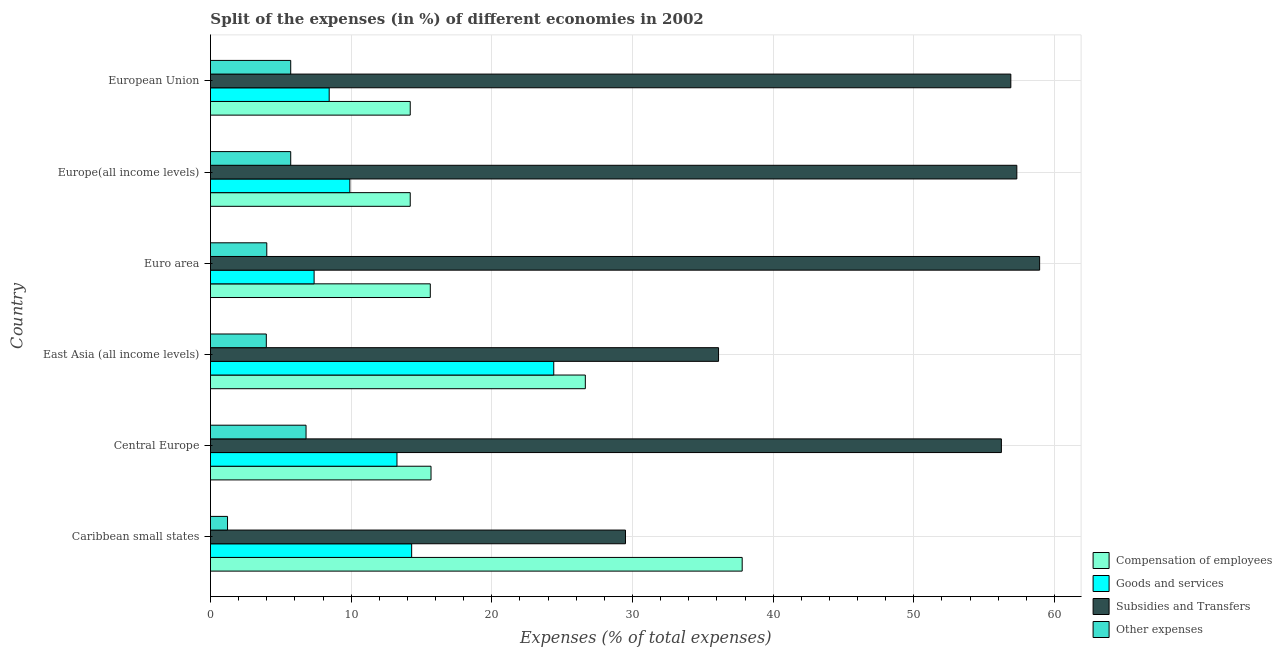How many different coloured bars are there?
Offer a very short reply. 4. Are the number of bars on each tick of the Y-axis equal?
Provide a succinct answer. Yes. How many bars are there on the 5th tick from the top?
Your response must be concise. 4. How many bars are there on the 3rd tick from the bottom?
Ensure brevity in your answer.  4. What is the label of the 6th group of bars from the top?
Your answer should be very brief. Caribbean small states. What is the percentage of amount spent on subsidies in East Asia (all income levels)?
Keep it short and to the point. 36.12. Across all countries, what is the maximum percentage of amount spent on subsidies?
Offer a terse response. 58.94. Across all countries, what is the minimum percentage of amount spent on compensation of employees?
Your answer should be very brief. 14.2. In which country was the percentage of amount spent on other expenses maximum?
Your response must be concise. Central Europe. In which country was the percentage of amount spent on other expenses minimum?
Ensure brevity in your answer.  Caribbean small states. What is the total percentage of amount spent on subsidies in the graph?
Provide a short and direct response. 295. What is the difference between the percentage of amount spent on subsidies in Euro area and that in Europe(all income levels)?
Provide a short and direct response. 1.62. What is the difference between the percentage of amount spent on other expenses in Central Europe and the percentage of amount spent on subsidies in Euro area?
Your answer should be compact. -52.15. What is the average percentage of amount spent on other expenses per country?
Your response must be concise. 4.56. What is the difference between the percentage of amount spent on compensation of employees and percentage of amount spent on other expenses in Euro area?
Provide a short and direct response. 11.62. In how many countries, is the percentage of amount spent on other expenses greater than 18 %?
Provide a succinct answer. 0. What is the ratio of the percentage of amount spent on compensation of employees in Central Europe to that in European Union?
Ensure brevity in your answer.  1.1. Is the percentage of amount spent on subsidies in Caribbean small states less than that in East Asia (all income levels)?
Keep it short and to the point. Yes. Is the difference between the percentage of amount spent on goods and services in Central Europe and Euro area greater than the difference between the percentage of amount spent on compensation of employees in Central Europe and Euro area?
Keep it short and to the point. Yes. What is the difference between the highest and the second highest percentage of amount spent on goods and services?
Provide a succinct answer. 10.1. What is the difference between the highest and the lowest percentage of amount spent on subsidies?
Ensure brevity in your answer.  29.44. Is the sum of the percentage of amount spent on subsidies in Caribbean small states and East Asia (all income levels) greater than the maximum percentage of amount spent on compensation of employees across all countries?
Your answer should be very brief. Yes. Is it the case that in every country, the sum of the percentage of amount spent on subsidies and percentage of amount spent on goods and services is greater than the sum of percentage of amount spent on other expenses and percentage of amount spent on compensation of employees?
Give a very brief answer. Yes. What does the 3rd bar from the top in Caribbean small states represents?
Make the answer very short. Goods and services. What does the 4th bar from the bottom in East Asia (all income levels) represents?
Ensure brevity in your answer.  Other expenses. Is it the case that in every country, the sum of the percentage of amount spent on compensation of employees and percentage of amount spent on goods and services is greater than the percentage of amount spent on subsidies?
Your response must be concise. No. How many bars are there?
Your response must be concise. 24. How many countries are there in the graph?
Offer a terse response. 6. What is the difference between two consecutive major ticks on the X-axis?
Your answer should be compact. 10. Are the values on the major ticks of X-axis written in scientific E-notation?
Your answer should be very brief. No. Does the graph contain any zero values?
Make the answer very short. No. Where does the legend appear in the graph?
Give a very brief answer. Bottom right. What is the title of the graph?
Your response must be concise. Split of the expenses (in %) of different economies in 2002. What is the label or title of the X-axis?
Offer a very short reply. Expenses (% of total expenses). What is the label or title of the Y-axis?
Offer a very short reply. Country. What is the Expenses (% of total expenses) of Compensation of employees in Caribbean small states?
Your answer should be compact. 37.8. What is the Expenses (% of total expenses) of Goods and services in Caribbean small states?
Provide a succinct answer. 14.3. What is the Expenses (% of total expenses) in Subsidies and Transfers in Caribbean small states?
Give a very brief answer. 29.5. What is the Expenses (% of total expenses) in Other expenses in Caribbean small states?
Ensure brevity in your answer.  1.21. What is the Expenses (% of total expenses) of Compensation of employees in Central Europe?
Ensure brevity in your answer.  15.68. What is the Expenses (% of total expenses) of Goods and services in Central Europe?
Keep it short and to the point. 13.26. What is the Expenses (% of total expenses) in Subsidies and Transfers in Central Europe?
Make the answer very short. 56.22. What is the Expenses (% of total expenses) in Other expenses in Central Europe?
Your answer should be compact. 6.79. What is the Expenses (% of total expenses) of Compensation of employees in East Asia (all income levels)?
Provide a short and direct response. 26.65. What is the Expenses (% of total expenses) in Goods and services in East Asia (all income levels)?
Your answer should be compact. 24.4. What is the Expenses (% of total expenses) in Subsidies and Transfers in East Asia (all income levels)?
Provide a short and direct response. 36.12. What is the Expenses (% of total expenses) in Other expenses in East Asia (all income levels)?
Your response must be concise. 3.97. What is the Expenses (% of total expenses) in Compensation of employees in Euro area?
Ensure brevity in your answer.  15.63. What is the Expenses (% of total expenses) of Goods and services in Euro area?
Ensure brevity in your answer.  7.37. What is the Expenses (% of total expenses) of Subsidies and Transfers in Euro area?
Give a very brief answer. 58.94. What is the Expenses (% of total expenses) in Other expenses in Euro area?
Provide a succinct answer. 4. What is the Expenses (% of total expenses) in Compensation of employees in Europe(all income levels)?
Your answer should be compact. 14.2. What is the Expenses (% of total expenses) in Goods and services in Europe(all income levels)?
Provide a short and direct response. 9.91. What is the Expenses (% of total expenses) of Subsidies and Transfers in Europe(all income levels)?
Your answer should be compact. 57.32. What is the Expenses (% of total expenses) in Other expenses in Europe(all income levels)?
Your answer should be very brief. 5.7. What is the Expenses (% of total expenses) in Compensation of employees in European Union?
Your answer should be very brief. 14.2. What is the Expenses (% of total expenses) of Goods and services in European Union?
Offer a terse response. 8.44. What is the Expenses (% of total expenses) in Subsidies and Transfers in European Union?
Make the answer very short. 56.89. What is the Expenses (% of total expenses) of Other expenses in European Union?
Make the answer very short. 5.7. Across all countries, what is the maximum Expenses (% of total expenses) of Compensation of employees?
Offer a very short reply. 37.8. Across all countries, what is the maximum Expenses (% of total expenses) in Goods and services?
Your answer should be compact. 24.4. Across all countries, what is the maximum Expenses (% of total expenses) in Subsidies and Transfers?
Keep it short and to the point. 58.94. Across all countries, what is the maximum Expenses (% of total expenses) of Other expenses?
Provide a succinct answer. 6.79. Across all countries, what is the minimum Expenses (% of total expenses) of Compensation of employees?
Make the answer very short. 14.2. Across all countries, what is the minimum Expenses (% of total expenses) in Goods and services?
Offer a very short reply. 7.37. Across all countries, what is the minimum Expenses (% of total expenses) in Subsidies and Transfers?
Keep it short and to the point. 29.5. Across all countries, what is the minimum Expenses (% of total expenses) of Other expenses?
Offer a terse response. 1.21. What is the total Expenses (% of total expenses) of Compensation of employees in the graph?
Your answer should be compact. 124.15. What is the total Expenses (% of total expenses) of Goods and services in the graph?
Provide a succinct answer. 77.67. What is the total Expenses (% of total expenses) in Subsidies and Transfers in the graph?
Provide a short and direct response. 295. What is the total Expenses (% of total expenses) in Other expenses in the graph?
Provide a short and direct response. 27.39. What is the difference between the Expenses (% of total expenses) of Compensation of employees in Caribbean small states and that in Central Europe?
Offer a terse response. 22.12. What is the difference between the Expenses (% of total expenses) of Goods and services in Caribbean small states and that in Central Europe?
Offer a terse response. 1.04. What is the difference between the Expenses (% of total expenses) in Subsidies and Transfers in Caribbean small states and that in Central Europe?
Your answer should be compact. -26.72. What is the difference between the Expenses (% of total expenses) in Other expenses in Caribbean small states and that in Central Europe?
Ensure brevity in your answer.  -5.58. What is the difference between the Expenses (% of total expenses) in Compensation of employees in Caribbean small states and that in East Asia (all income levels)?
Offer a very short reply. 11.15. What is the difference between the Expenses (% of total expenses) of Goods and services in Caribbean small states and that in East Asia (all income levels)?
Your answer should be very brief. -10.1. What is the difference between the Expenses (% of total expenses) of Subsidies and Transfers in Caribbean small states and that in East Asia (all income levels)?
Keep it short and to the point. -6.62. What is the difference between the Expenses (% of total expenses) in Other expenses in Caribbean small states and that in East Asia (all income levels)?
Ensure brevity in your answer.  -2.76. What is the difference between the Expenses (% of total expenses) of Compensation of employees in Caribbean small states and that in Euro area?
Offer a very short reply. 22.17. What is the difference between the Expenses (% of total expenses) of Goods and services in Caribbean small states and that in Euro area?
Keep it short and to the point. 6.93. What is the difference between the Expenses (% of total expenses) of Subsidies and Transfers in Caribbean small states and that in Euro area?
Provide a short and direct response. -29.44. What is the difference between the Expenses (% of total expenses) of Other expenses in Caribbean small states and that in Euro area?
Ensure brevity in your answer.  -2.79. What is the difference between the Expenses (% of total expenses) of Compensation of employees in Caribbean small states and that in Europe(all income levels)?
Your answer should be compact. 23.6. What is the difference between the Expenses (% of total expenses) of Goods and services in Caribbean small states and that in Europe(all income levels)?
Make the answer very short. 4.39. What is the difference between the Expenses (% of total expenses) in Subsidies and Transfers in Caribbean small states and that in Europe(all income levels)?
Provide a succinct answer. -27.82. What is the difference between the Expenses (% of total expenses) of Other expenses in Caribbean small states and that in Europe(all income levels)?
Provide a succinct answer. -4.49. What is the difference between the Expenses (% of total expenses) in Compensation of employees in Caribbean small states and that in European Union?
Your response must be concise. 23.6. What is the difference between the Expenses (% of total expenses) in Goods and services in Caribbean small states and that in European Union?
Give a very brief answer. 5.86. What is the difference between the Expenses (% of total expenses) in Subsidies and Transfers in Caribbean small states and that in European Union?
Offer a very short reply. -27.39. What is the difference between the Expenses (% of total expenses) in Other expenses in Caribbean small states and that in European Union?
Offer a terse response. -4.49. What is the difference between the Expenses (% of total expenses) of Compensation of employees in Central Europe and that in East Asia (all income levels)?
Provide a succinct answer. -10.97. What is the difference between the Expenses (% of total expenses) in Goods and services in Central Europe and that in East Asia (all income levels)?
Make the answer very short. -11.14. What is the difference between the Expenses (% of total expenses) in Subsidies and Transfers in Central Europe and that in East Asia (all income levels)?
Your answer should be very brief. 20.11. What is the difference between the Expenses (% of total expenses) of Other expenses in Central Europe and that in East Asia (all income levels)?
Make the answer very short. 2.82. What is the difference between the Expenses (% of total expenses) in Compensation of employees in Central Europe and that in Euro area?
Offer a terse response. 0.05. What is the difference between the Expenses (% of total expenses) in Goods and services in Central Europe and that in Euro area?
Provide a succinct answer. 5.89. What is the difference between the Expenses (% of total expenses) in Subsidies and Transfers in Central Europe and that in Euro area?
Provide a succinct answer. -2.72. What is the difference between the Expenses (% of total expenses) in Other expenses in Central Europe and that in Euro area?
Make the answer very short. 2.79. What is the difference between the Expenses (% of total expenses) in Compensation of employees in Central Europe and that in Europe(all income levels)?
Provide a succinct answer. 1.48. What is the difference between the Expenses (% of total expenses) of Goods and services in Central Europe and that in Europe(all income levels)?
Provide a succinct answer. 3.35. What is the difference between the Expenses (% of total expenses) of Subsidies and Transfers in Central Europe and that in Europe(all income levels)?
Offer a terse response. -1.1. What is the difference between the Expenses (% of total expenses) in Other expenses in Central Europe and that in Europe(all income levels)?
Provide a succinct answer. 1.09. What is the difference between the Expenses (% of total expenses) in Compensation of employees in Central Europe and that in European Union?
Your response must be concise. 1.48. What is the difference between the Expenses (% of total expenses) of Goods and services in Central Europe and that in European Union?
Give a very brief answer. 4.82. What is the difference between the Expenses (% of total expenses) of Subsidies and Transfers in Central Europe and that in European Union?
Your answer should be compact. -0.67. What is the difference between the Expenses (% of total expenses) in Other expenses in Central Europe and that in European Union?
Your response must be concise. 1.09. What is the difference between the Expenses (% of total expenses) in Compensation of employees in East Asia (all income levels) and that in Euro area?
Keep it short and to the point. 11.02. What is the difference between the Expenses (% of total expenses) in Goods and services in East Asia (all income levels) and that in Euro area?
Ensure brevity in your answer.  17.03. What is the difference between the Expenses (% of total expenses) in Subsidies and Transfers in East Asia (all income levels) and that in Euro area?
Your answer should be very brief. -22.82. What is the difference between the Expenses (% of total expenses) in Other expenses in East Asia (all income levels) and that in Euro area?
Provide a short and direct response. -0.03. What is the difference between the Expenses (% of total expenses) in Compensation of employees in East Asia (all income levels) and that in Europe(all income levels)?
Your answer should be compact. 12.45. What is the difference between the Expenses (% of total expenses) in Goods and services in East Asia (all income levels) and that in Europe(all income levels)?
Offer a terse response. 14.49. What is the difference between the Expenses (% of total expenses) in Subsidies and Transfers in East Asia (all income levels) and that in Europe(all income levels)?
Ensure brevity in your answer.  -21.2. What is the difference between the Expenses (% of total expenses) in Other expenses in East Asia (all income levels) and that in Europe(all income levels)?
Ensure brevity in your answer.  -1.74. What is the difference between the Expenses (% of total expenses) of Compensation of employees in East Asia (all income levels) and that in European Union?
Give a very brief answer. 12.45. What is the difference between the Expenses (% of total expenses) of Goods and services in East Asia (all income levels) and that in European Union?
Provide a short and direct response. 15.96. What is the difference between the Expenses (% of total expenses) in Subsidies and Transfers in East Asia (all income levels) and that in European Union?
Your response must be concise. -20.78. What is the difference between the Expenses (% of total expenses) in Other expenses in East Asia (all income levels) and that in European Union?
Give a very brief answer. -1.74. What is the difference between the Expenses (% of total expenses) of Compensation of employees in Euro area and that in Europe(all income levels)?
Your response must be concise. 1.43. What is the difference between the Expenses (% of total expenses) of Goods and services in Euro area and that in Europe(all income levels)?
Keep it short and to the point. -2.54. What is the difference between the Expenses (% of total expenses) of Subsidies and Transfers in Euro area and that in Europe(all income levels)?
Your response must be concise. 1.62. What is the difference between the Expenses (% of total expenses) of Other expenses in Euro area and that in Europe(all income levels)?
Provide a short and direct response. -1.7. What is the difference between the Expenses (% of total expenses) of Compensation of employees in Euro area and that in European Union?
Offer a very short reply. 1.43. What is the difference between the Expenses (% of total expenses) of Goods and services in Euro area and that in European Union?
Provide a short and direct response. -1.07. What is the difference between the Expenses (% of total expenses) in Subsidies and Transfers in Euro area and that in European Union?
Offer a very short reply. 2.05. What is the difference between the Expenses (% of total expenses) in Other expenses in Euro area and that in European Union?
Make the answer very short. -1.7. What is the difference between the Expenses (% of total expenses) of Compensation of employees in Europe(all income levels) and that in European Union?
Provide a succinct answer. 0. What is the difference between the Expenses (% of total expenses) in Goods and services in Europe(all income levels) and that in European Union?
Your answer should be compact. 1.47. What is the difference between the Expenses (% of total expenses) in Subsidies and Transfers in Europe(all income levels) and that in European Union?
Your answer should be very brief. 0.43. What is the difference between the Expenses (% of total expenses) in Other expenses in Europe(all income levels) and that in European Union?
Provide a succinct answer. 0. What is the difference between the Expenses (% of total expenses) in Compensation of employees in Caribbean small states and the Expenses (% of total expenses) in Goods and services in Central Europe?
Offer a very short reply. 24.54. What is the difference between the Expenses (% of total expenses) of Compensation of employees in Caribbean small states and the Expenses (% of total expenses) of Subsidies and Transfers in Central Europe?
Your answer should be compact. -18.43. What is the difference between the Expenses (% of total expenses) of Compensation of employees in Caribbean small states and the Expenses (% of total expenses) of Other expenses in Central Europe?
Your answer should be compact. 31. What is the difference between the Expenses (% of total expenses) of Goods and services in Caribbean small states and the Expenses (% of total expenses) of Subsidies and Transfers in Central Europe?
Your answer should be very brief. -41.92. What is the difference between the Expenses (% of total expenses) of Goods and services in Caribbean small states and the Expenses (% of total expenses) of Other expenses in Central Europe?
Provide a succinct answer. 7.51. What is the difference between the Expenses (% of total expenses) of Subsidies and Transfers in Caribbean small states and the Expenses (% of total expenses) of Other expenses in Central Europe?
Give a very brief answer. 22.71. What is the difference between the Expenses (% of total expenses) in Compensation of employees in Caribbean small states and the Expenses (% of total expenses) in Goods and services in East Asia (all income levels)?
Your answer should be compact. 13.4. What is the difference between the Expenses (% of total expenses) of Compensation of employees in Caribbean small states and the Expenses (% of total expenses) of Subsidies and Transfers in East Asia (all income levels)?
Your answer should be compact. 1.68. What is the difference between the Expenses (% of total expenses) in Compensation of employees in Caribbean small states and the Expenses (% of total expenses) in Other expenses in East Asia (all income levels)?
Your answer should be very brief. 33.83. What is the difference between the Expenses (% of total expenses) in Goods and services in Caribbean small states and the Expenses (% of total expenses) in Subsidies and Transfers in East Asia (all income levels)?
Offer a terse response. -21.82. What is the difference between the Expenses (% of total expenses) in Goods and services in Caribbean small states and the Expenses (% of total expenses) in Other expenses in East Asia (all income levels)?
Provide a succinct answer. 10.33. What is the difference between the Expenses (% of total expenses) in Subsidies and Transfers in Caribbean small states and the Expenses (% of total expenses) in Other expenses in East Asia (all income levels)?
Give a very brief answer. 25.53. What is the difference between the Expenses (% of total expenses) in Compensation of employees in Caribbean small states and the Expenses (% of total expenses) in Goods and services in Euro area?
Provide a short and direct response. 30.43. What is the difference between the Expenses (% of total expenses) of Compensation of employees in Caribbean small states and the Expenses (% of total expenses) of Subsidies and Transfers in Euro area?
Make the answer very short. -21.14. What is the difference between the Expenses (% of total expenses) of Compensation of employees in Caribbean small states and the Expenses (% of total expenses) of Other expenses in Euro area?
Offer a terse response. 33.8. What is the difference between the Expenses (% of total expenses) in Goods and services in Caribbean small states and the Expenses (% of total expenses) in Subsidies and Transfers in Euro area?
Your response must be concise. -44.64. What is the difference between the Expenses (% of total expenses) in Goods and services in Caribbean small states and the Expenses (% of total expenses) in Other expenses in Euro area?
Provide a short and direct response. 10.3. What is the difference between the Expenses (% of total expenses) of Subsidies and Transfers in Caribbean small states and the Expenses (% of total expenses) of Other expenses in Euro area?
Your response must be concise. 25.5. What is the difference between the Expenses (% of total expenses) of Compensation of employees in Caribbean small states and the Expenses (% of total expenses) of Goods and services in Europe(all income levels)?
Give a very brief answer. 27.89. What is the difference between the Expenses (% of total expenses) of Compensation of employees in Caribbean small states and the Expenses (% of total expenses) of Subsidies and Transfers in Europe(all income levels)?
Give a very brief answer. -19.52. What is the difference between the Expenses (% of total expenses) in Compensation of employees in Caribbean small states and the Expenses (% of total expenses) in Other expenses in Europe(all income levels)?
Make the answer very short. 32.09. What is the difference between the Expenses (% of total expenses) in Goods and services in Caribbean small states and the Expenses (% of total expenses) in Subsidies and Transfers in Europe(all income levels)?
Ensure brevity in your answer.  -43.02. What is the difference between the Expenses (% of total expenses) of Goods and services in Caribbean small states and the Expenses (% of total expenses) of Other expenses in Europe(all income levels)?
Offer a terse response. 8.6. What is the difference between the Expenses (% of total expenses) of Subsidies and Transfers in Caribbean small states and the Expenses (% of total expenses) of Other expenses in Europe(all income levels)?
Provide a short and direct response. 23.8. What is the difference between the Expenses (% of total expenses) in Compensation of employees in Caribbean small states and the Expenses (% of total expenses) in Goods and services in European Union?
Your response must be concise. 29.36. What is the difference between the Expenses (% of total expenses) in Compensation of employees in Caribbean small states and the Expenses (% of total expenses) in Subsidies and Transfers in European Union?
Give a very brief answer. -19.1. What is the difference between the Expenses (% of total expenses) in Compensation of employees in Caribbean small states and the Expenses (% of total expenses) in Other expenses in European Union?
Your answer should be compact. 32.09. What is the difference between the Expenses (% of total expenses) in Goods and services in Caribbean small states and the Expenses (% of total expenses) in Subsidies and Transfers in European Union?
Keep it short and to the point. -42.59. What is the difference between the Expenses (% of total expenses) of Goods and services in Caribbean small states and the Expenses (% of total expenses) of Other expenses in European Union?
Provide a short and direct response. 8.6. What is the difference between the Expenses (% of total expenses) in Subsidies and Transfers in Caribbean small states and the Expenses (% of total expenses) in Other expenses in European Union?
Your answer should be very brief. 23.8. What is the difference between the Expenses (% of total expenses) of Compensation of employees in Central Europe and the Expenses (% of total expenses) of Goods and services in East Asia (all income levels)?
Make the answer very short. -8.72. What is the difference between the Expenses (% of total expenses) of Compensation of employees in Central Europe and the Expenses (% of total expenses) of Subsidies and Transfers in East Asia (all income levels)?
Your response must be concise. -20.44. What is the difference between the Expenses (% of total expenses) of Compensation of employees in Central Europe and the Expenses (% of total expenses) of Other expenses in East Asia (all income levels)?
Make the answer very short. 11.71. What is the difference between the Expenses (% of total expenses) of Goods and services in Central Europe and the Expenses (% of total expenses) of Subsidies and Transfers in East Asia (all income levels)?
Provide a succinct answer. -22.86. What is the difference between the Expenses (% of total expenses) in Goods and services in Central Europe and the Expenses (% of total expenses) in Other expenses in East Asia (all income levels)?
Give a very brief answer. 9.29. What is the difference between the Expenses (% of total expenses) of Subsidies and Transfers in Central Europe and the Expenses (% of total expenses) of Other expenses in East Asia (all income levels)?
Make the answer very short. 52.25. What is the difference between the Expenses (% of total expenses) of Compensation of employees in Central Europe and the Expenses (% of total expenses) of Goods and services in Euro area?
Keep it short and to the point. 8.31. What is the difference between the Expenses (% of total expenses) of Compensation of employees in Central Europe and the Expenses (% of total expenses) of Subsidies and Transfers in Euro area?
Your answer should be compact. -43.26. What is the difference between the Expenses (% of total expenses) of Compensation of employees in Central Europe and the Expenses (% of total expenses) of Other expenses in Euro area?
Offer a very short reply. 11.68. What is the difference between the Expenses (% of total expenses) in Goods and services in Central Europe and the Expenses (% of total expenses) in Subsidies and Transfers in Euro area?
Provide a succinct answer. -45.68. What is the difference between the Expenses (% of total expenses) of Goods and services in Central Europe and the Expenses (% of total expenses) of Other expenses in Euro area?
Offer a very short reply. 9.25. What is the difference between the Expenses (% of total expenses) of Subsidies and Transfers in Central Europe and the Expenses (% of total expenses) of Other expenses in Euro area?
Provide a short and direct response. 52.22. What is the difference between the Expenses (% of total expenses) of Compensation of employees in Central Europe and the Expenses (% of total expenses) of Goods and services in Europe(all income levels)?
Make the answer very short. 5.77. What is the difference between the Expenses (% of total expenses) of Compensation of employees in Central Europe and the Expenses (% of total expenses) of Subsidies and Transfers in Europe(all income levels)?
Provide a succinct answer. -41.64. What is the difference between the Expenses (% of total expenses) in Compensation of employees in Central Europe and the Expenses (% of total expenses) in Other expenses in Europe(all income levels)?
Make the answer very short. 9.97. What is the difference between the Expenses (% of total expenses) in Goods and services in Central Europe and the Expenses (% of total expenses) in Subsidies and Transfers in Europe(all income levels)?
Offer a terse response. -44.06. What is the difference between the Expenses (% of total expenses) in Goods and services in Central Europe and the Expenses (% of total expenses) in Other expenses in Europe(all income levels)?
Ensure brevity in your answer.  7.55. What is the difference between the Expenses (% of total expenses) of Subsidies and Transfers in Central Europe and the Expenses (% of total expenses) of Other expenses in Europe(all income levels)?
Your answer should be very brief. 50.52. What is the difference between the Expenses (% of total expenses) of Compensation of employees in Central Europe and the Expenses (% of total expenses) of Goods and services in European Union?
Your answer should be compact. 7.24. What is the difference between the Expenses (% of total expenses) of Compensation of employees in Central Europe and the Expenses (% of total expenses) of Subsidies and Transfers in European Union?
Keep it short and to the point. -41.22. What is the difference between the Expenses (% of total expenses) in Compensation of employees in Central Europe and the Expenses (% of total expenses) in Other expenses in European Union?
Your answer should be very brief. 9.97. What is the difference between the Expenses (% of total expenses) in Goods and services in Central Europe and the Expenses (% of total expenses) in Subsidies and Transfers in European Union?
Offer a very short reply. -43.64. What is the difference between the Expenses (% of total expenses) of Goods and services in Central Europe and the Expenses (% of total expenses) of Other expenses in European Union?
Ensure brevity in your answer.  7.55. What is the difference between the Expenses (% of total expenses) in Subsidies and Transfers in Central Europe and the Expenses (% of total expenses) in Other expenses in European Union?
Keep it short and to the point. 50.52. What is the difference between the Expenses (% of total expenses) of Compensation of employees in East Asia (all income levels) and the Expenses (% of total expenses) of Goods and services in Euro area?
Make the answer very short. 19.28. What is the difference between the Expenses (% of total expenses) of Compensation of employees in East Asia (all income levels) and the Expenses (% of total expenses) of Subsidies and Transfers in Euro area?
Provide a short and direct response. -32.29. What is the difference between the Expenses (% of total expenses) in Compensation of employees in East Asia (all income levels) and the Expenses (% of total expenses) in Other expenses in Euro area?
Offer a terse response. 22.64. What is the difference between the Expenses (% of total expenses) in Goods and services in East Asia (all income levels) and the Expenses (% of total expenses) in Subsidies and Transfers in Euro area?
Give a very brief answer. -34.54. What is the difference between the Expenses (% of total expenses) in Goods and services in East Asia (all income levels) and the Expenses (% of total expenses) in Other expenses in Euro area?
Provide a short and direct response. 20.4. What is the difference between the Expenses (% of total expenses) of Subsidies and Transfers in East Asia (all income levels) and the Expenses (% of total expenses) of Other expenses in Euro area?
Keep it short and to the point. 32.11. What is the difference between the Expenses (% of total expenses) in Compensation of employees in East Asia (all income levels) and the Expenses (% of total expenses) in Goods and services in Europe(all income levels)?
Provide a succinct answer. 16.74. What is the difference between the Expenses (% of total expenses) in Compensation of employees in East Asia (all income levels) and the Expenses (% of total expenses) in Subsidies and Transfers in Europe(all income levels)?
Offer a very short reply. -30.67. What is the difference between the Expenses (% of total expenses) in Compensation of employees in East Asia (all income levels) and the Expenses (% of total expenses) in Other expenses in Europe(all income levels)?
Offer a terse response. 20.94. What is the difference between the Expenses (% of total expenses) in Goods and services in East Asia (all income levels) and the Expenses (% of total expenses) in Subsidies and Transfers in Europe(all income levels)?
Make the answer very short. -32.92. What is the difference between the Expenses (% of total expenses) of Goods and services in East Asia (all income levels) and the Expenses (% of total expenses) of Other expenses in Europe(all income levels)?
Your response must be concise. 18.7. What is the difference between the Expenses (% of total expenses) of Subsidies and Transfers in East Asia (all income levels) and the Expenses (% of total expenses) of Other expenses in Europe(all income levels)?
Provide a succinct answer. 30.41. What is the difference between the Expenses (% of total expenses) in Compensation of employees in East Asia (all income levels) and the Expenses (% of total expenses) in Goods and services in European Union?
Your answer should be very brief. 18.21. What is the difference between the Expenses (% of total expenses) in Compensation of employees in East Asia (all income levels) and the Expenses (% of total expenses) in Subsidies and Transfers in European Union?
Your answer should be very brief. -30.25. What is the difference between the Expenses (% of total expenses) in Compensation of employees in East Asia (all income levels) and the Expenses (% of total expenses) in Other expenses in European Union?
Ensure brevity in your answer.  20.94. What is the difference between the Expenses (% of total expenses) of Goods and services in East Asia (all income levels) and the Expenses (% of total expenses) of Subsidies and Transfers in European Union?
Your answer should be very brief. -32.49. What is the difference between the Expenses (% of total expenses) in Goods and services in East Asia (all income levels) and the Expenses (% of total expenses) in Other expenses in European Union?
Keep it short and to the point. 18.7. What is the difference between the Expenses (% of total expenses) in Subsidies and Transfers in East Asia (all income levels) and the Expenses (% of total expenses) in Other expenses in European Union?
Make the answer very short. 30.41. What is the difference between the Expenses (% of total expenses) of Compensation of employees in Euro area and the Expenses (% of total expenses) of Goods and services in Europe(all income levels)?
Your response must be concise. 5.72. What is the difference between the Expenses (% of total expenses) in Compensation of employees in Euro area and the Expenses (% of total expenses) in Subsidies and Transfers in Europe(all income levels)?
Your answer should be very brief. -41.69. What is the difference between the Expenses (% of total expenses) of Compensation of employees in Euro area and the Expenses (% of total expenses) of Other expenses in Europe(all income levels)?
Your answer should be compact. 9.92. What is the difference between the Expenses (% of total expenses) in Goods and services in Euro area and the Expenses (% of total expenses) in Subsidies and Transfers in Europe(all income levels)?
Your answer should be very brief. -49.95. What is the difference between the Expenses (% of total expenses) in Goods and services in Euro area and the Expenses (% of total expenses) in Other expenses in Europe(all income levels)?
Your answer should be very brief. 1.66. What is the difference between the Expenses (% of total expenses) of Subsidies and Transfers in Euro area and the Expenses (% of total expenses) of Other expenses in Europe(all income levels)?
Your answer should be very brief. 53.24. What is the difference between the Expenses (% of total expenses) in Compensation of employees in Euro area and the Expenses (% of total expenses) in Goods and services in European Union?
Ensure brevity in your answer.  7.19. What is the difference between the Expenses (% of total expenses) of Compensation of employees in Euro area and the Expenses (% of total expenses) of Subsidies and Transfers in European Union?
Ensure brevity in your answer.  -41.27. What is the difference between the Expenses (% of total expenses) in Compensation of employees in Euro area and the Expenses (% of total expenses) in Other expenses in European Union?
Keep it short and to the point. 9.92. What is the difference between the Expenses (% of total expenses) of Goods and services in Euro area and the Expenses (% of total expenses) of Subsidies and Transfers in European Union?
Your answer should be very brief. -49.53. What is the difference between the Expenses (% of total expenses) of Goods and services in Euro area and the Expenses (% of total expenses) of Other expenses in European Union?
Offer a terse response. 1.66. What is the difference between the Expenses (% of total expenses) of Subsidies and Transfers in Euro area and the Expenses (% of total expenses) of Other expenses in European Union?
Provide a succinct answer. 53.24. What is the difference between the Expenses (% of total expenses) of Compensation of employees in Europe(all income levels) and the Expenses (% of total expenses) of Goods and services in European Union?
Your answer should be compact. 5.76. What is the difference between the Expenses (% of total expenses) of Compensation of employees in Europe(all income levels) and the Expenses (% of total expenses) of Subsidies and Transfers in European Union?
Your answer should be compact. -42.69. What is the difference between the Expenses (% of total expenses) of Compensation of employees in Europe(all income levels) and the Expenses (% of total expenses) of Other expenses in European Union?
Offer a terse response. 8.5. What is the difference between the Expenses (% of total expenses) in Goods and services in Europe(all income levels) and the Expenses (% of total expenses) in Subsidies and Transfers in European Union?
Make the answer very short. -46.99. What is the difference between the Expenses (% of total expenses) of Goods and services in Europe(all income levels) and the Expenses (% of total expenses) of Other expenses in European Union?
Your answer should be very brief. 4.2. What is the difference between the Expenses (% of total expenses) in Subsidies and Transfers in Europe(all income levels) and the Expenses (% of total expenses) in Other expenses in European Union?
Provide a succinct answer. 51.62. What is the average Expenses (% of total expenses) of Compensation of employees per country?
Your answer should be compact. 20.69. What is the average Expenses (% of total expenses) in Goods and services per country?
Offer a terse response. 12.95. What is the average Expenses (% of total expenses) in Subsidies and Transfers per country?
Offer a terse response. 49.17. What is the average Expenses (% of total expenses) of Other expenses per country?
Offer a terse response. 4.56. What is the difference between the Expenses (% of total expenses) in Compensation of employees and Expenses (% of total expenses) in Goods and services in Caribbean small states?
Keep it short and to the point. 23.5. What is the difference between the Expenses (% of total expenses) in Compensation of employees and Expenses (% of total expenses) in Subsidies and Transfers in Caribbean small states?
Give a very brief answer. 8.3. What is the difference between the Expenses (% of total expenses) of Compensation of employees and Expenses (% of total expenses) of Other expenses in Caribbean small states?
Your answer should be compact. 36.59. What is the difference between the Expenses (% of total expenses) of Goods and services and Expenses (% of total expenses) of Subsidies and Transfers in Caribbean small states?
Provide a short and direct response. -15.2. What is the difference between the Expenses (% of total expenses) in Goods and services and Expenses (% of total expenses) in Other expenses in Caribbean small states?
Provide a short and direct response. 13.09. What is the difference between the Expenses (% of total expenses) of Subsidies and Transfers and Expenses (% of total expenses) of Other expenses in Caribbean small states?
Make the answer very short. 28.29. What is the difference between the Expenses (% of total expenses) of Compensation of employees and Expenses (% of total expenses) of Goods and services in Central Europe?
Provide a short and direct response. 2.42. What is the difference between the Expenses (% of total expenses) of Compensation of employees and Expenses (% of total expenses) of Subsidies and Transfers in Central Europe?
Give a very brief answer. -40.55. What is the difference between the Expenses (% of total expenses) in Compensation of employees and Expenses (% of total expenses) in Other expenses in Central Europe?
Your answer should be compact. 8.88. What is the difference between the Expenses (% of total expenses) of Goods and services and Expenses (% of total expenses) of Subsidies and Transfers in Central Europe?
Offer a terse response. -42.97. What is the difference between the Expenses (% of total expenses) in Goods and services and Expenses (% of total expenses) in Other expenses in Central Europe?
Your answer should be compact. 6.46. What is the difference between the Expenses (% of total expenses) of Subsidies and Transfers and Expenses (% of total expenses) of Other expenses in Central Europe?
Your response must be concise. 49.43. What is the difference between the Expenses (% of total expenses) of Compensation of employees and Expenses (% of total expenses) of Goods and services in East Asia (all income levels)?
Make the answer very short. 2.25. What is the difference between the Expenses (% of total expenses) of Compensation of employees and Expenses (% of total expenses) of Subsidies and Transfers in East Asia (all income levels)?
Your answer should be very brief. -9.47. What is the difference between the Expenses (% of total expenses) in Compensation of employees and Expenses (% of total expenses) in Other expenses in East Asia (all income levels)?
Provide a succinct answer. 22.68. What is the difference between the Expenses (% of total expenses) in Goods and services and Expenses (% of total expenses) in Subsidies and Transfers in East Asia (all income levels)?
Make the answer very short. -11.72. What is the difference between the Expenses (% of total expenses) of Goods and services and Expenses (% of total expenses) of Other expenses in East Asia (all income levels)?
Your answer should be very brief. 20.43. What is the difference between the Expenses (% of total expenses) in Subsidies and Transfers and Expenses (% of total expenses) in Other expenses in East Asia (all income levels)?
Your answer should be compact. 32.15. What is the difference between the Expenses (% of total expenses) of Compensation of employees and Expenses (% of total expenses) of Goods and services in Euro area?
Provide a succinct answer. 8.26. What is the difference between the Expenses (% of total expenses) of Compensation of employees and Expenses (% of total expenses) of Subsidies and Transfers in Euro area?
Ensure brevity in your answer.  -43.32. What is the difference between the Expenses (% of total expenses) of Compensation of employees and Expenses (% of total expenses) of Other expenses in Euro area?
Keep it short and to the point. 11.62. What is the difference between the Expenses (% of total expenses) in Goods and services and Expenses (% of total expenses) in Subsidies and Transfers in Euro area?
Your answer should be very brief. -51.57. What is the difference between the Expenses (% of total expenses) of Goods and services and Expenses (% of total expenses) of Other expenses in Euro area?
Your answer should be compact. 3.36. What is the difference between the Expenses (% of total expenses) of Subsidies and Transfers and Expenses (% of total expenses) of Other expenses in Euro area?
Your response must be concise. 54.94. What is the difference between the Expenses (% of total expenses) in Compensation of employees and Expenses (% of total expenses) in Goods and services in Europe(all income levels)?
Your answer should be very brief. 4.29. What is the difference between the Expenses (% of total expenses) in Compensation of employees and Expenses (% of total expenses) in Subsidies and Transfers in Europe(all income levels)?
Your answer should be compact. -43.12. What is the difference between the Expenses (% of total expenses) in Compensation of employees and Expenses (% of total expenses) in Other expenses in Europe(all income levels)?
Offer a very short reply. 8.5. What is the difference between the Expenses (% of total expenses) in Goods and services and Expenses (% of total expenses) in Subsidies and Transfers in Europe(all income levels)?
Provide a short and direct response. -47.41. What is the difference between the Expenses (% of total expenses) in Goods and services and Expenses (% of total expenses) in Other expenses in Europe(all income levels)?
Ensure brevity in your answer.  4.2. What is the difference between the Expenses (% of total expenses) in Subsidies and Transfers and Expenses (% of total expenses) in Other expenses in Europe(all income levels)?
Keep it short and to the point. 51.62. What is the difference between the Expenses (% of total expenses) of Compensation of employees and Expenses (% of total expenses) of Goods and services in European Union?
Offer a terse response. 5.76. What is the difference between the Expenses (% of total expenses) of Compensation of employees and Expenses (% of total expenses) of Subsidies and Transfers in European Union?
Provide a short and direct response. -42.69. What is the difference between the Expenses (% of total expenses) of Compensation of employees and Expenses (% of total expenses) of Other expenses in European Union?
Keep it short and to the point. 8.5. What is the difference between the Expenses (% of total expenses) in Goods and services and Expenses (% of total expenses) in Subsidies and Transfers in European Union?
Offer a terse response. -48.46. What is the difference between the Expenses (% of total expenses) in Goods and services and Expenses (% of total expenses) in Other expenses in European Union?
Provide a succinct answer. 2.73. What is the difference between the Expenses (% of total expenses) in Subsidies and Transfers and Expenses (% of total expenses) in Other expenses in European Union?
Ensure brevity in your answer.  51.19. What is the ratio of the Expenses (% of total expenses) in Compensation of employees in Caribbean small states to that in Central Europe?
Provide a short and direct response. 2.41. What is the ratio of the Expenses (% of total expenses) in Goods and services in Caribbean small states to that in Central Europe?
Ensure brevity in your answer.  1.08. What is the ratio of the Expenses (% of total expenses) in Subsidies and Transfers in Caribbean small states to that in Central Europe?
Offer a terse response. 0.52. What is the ratio of the Expenses (% of total expenses) of Other expenses in Caribbean small states to that in Central Europe?
Offer a terse response. 0.18. What is the ratio of the Expenses (% of total expenses) of Compensation of employees in Caribbean small states to that in East Asia (all income levels)?
Your answer should be compact. 1.42. What is the ratio of the Expenses (% of total expenses) of Goods and services in Caribbean small states to that in East Asia (all income levels)?
Ensure brevity in your answer.  0.59. What is the ratio of the Expenses (% of total expenses) of Subsidies and Transfers in Caribbean small states to that in East Asia (all income levels)?
Offer a very short reply. 0.82. What is the ratio of the Expenses (% of total expenses) of Other expenses in Caribbean small states to that in East Asia (all income levels)?
Make the answer very short. 0.31. What is the ratio of the Expenses (% of total expenses) in Compensation of employees in Caribbean small states to that in Euro area?
Offer a terse response. 2.42. What is the ratio of the Expenses (% of total expenses) in Goods and services in Caribbean small states to that in Euro area?
Give a very brief answer. 1.94. What is the ratio of the Expenses (% of total expenses) in Subsidies and Transfers in Caribbean small states to that in Euro area?
Provide a short and direct response. 0.5. What is the ratio of the Expenses (% of total expenses) in Other expenses in Caribbean small states to that in Euro area?
Provide a short and direct response. 0.3. What is the ratio of the Expenses (% of total expenses) of Compensation of employees in Caribbean small states to that in Europe(all income levels)?
Provide a short and direct response. 2.66. What is the ratio of the Expenses (% of total expenses) in Goods and services in Caribbean small states to that in Europe(all income levels)?
Make the answer very short. 1.44. What is the ratio of the Expenses (% of total expenses) in Subsidies and Transfers in Caribbean small states to that in Europe(all income levels)?
Keep it short and to the point. 0.51. What is the ratio of the Expenses (% of total expenses) in Other expenses in Caribbean small states to that in Europe(all income levels)?
Offer a terse response. 0.21. What is the ratio of the Expenses (% of total expenses) in Compensation of employees in Caribbean small states to that in European Union?
Offer a very short reply. 2.66. What is the ratio of the Expenses (% of total expenses) in Goods and services in Caribbean small states to that in European Union?
Your answer should be compact. 1.69. What is the ratio of the Expenses (% of total expenses) of Subsidies and Transfers in Caribbean small states to that in European Union?
Offer a terse response. 0.52. What is the ratio of the Expenses (% of total expenses) of Other expenses in Caribbean small states to that in European Union?
Your answer should be compact. 0.21. What is the ratio of the Expenses (% of total expenses) in Compensation of employees in Central Europe to that in East Asia (all income levels)?
Keep it short and to the point. 0.59. What is the ratio of the Expenses (% of total expenses) in Goods and services in Central Europe to that in East Asia (all income levels)?
Your answer should be compact. 0.54. What is the ratio of the Expenses (% of total expenses) of Subsidies and Transfers in Central Europe to that in East Asia (all income levels)?
Keep it short and to the point. 1.56. What is the ratio of the Expenses (% of total expenses) of Other expenses in Central Europe to that in East Asia (all income levels)?
Provide a succinct answer. 1.71. What is the ratio of the Expenses (% of total expenses) of Compensation of employees in Central Europe to that in Euro area?
Provide a short and direct response. 1. What is the ratio of the Expenses (% of total expenses) in Goods and services in Central Europe to that in Euro area?
Keep it short and to the point. 1.8. What is the ratio of the Expenses (% of total expenses) of Subsidies and Transfers in Central Europe to that in Euro area?
Your response must be concise. 0.95. What is the ratio of the Expenses (% of total expenses) in Other expenses in Central Europe to that in Euro area?
Your answer should be compact. 1.7. What is the ratio of the Expenses (% of total expenses) of Compensation of employees in Central Europe to that in Europe(all income levels)?
Your answer should be very brief. 1.1. What is the ratio of the Expenses (% of total expenses) in Goods and services in Central Europe to that in Europe(all income levels)?
Your answer should be compact. 1.34. What is the ratio of the Expenses (% of total expenses) of Subsidies and Transfers in Central Europe to that in Europe(all income levels)?
Provide a short and direct response. 0.98. What is the ratio of the Expenses (% of total expenses) in Other expenses in Central Europe to that in Europe(all income levels)?
Make the answer very short. 1.19. What is the ratio of the Expenses (% of total expenses) of Compensation of employees in Central Europe to that in European Union?
Give a very brief answer. 1.1. What is the ratio of the Expenses (% of total expenses) in Goods and services in Central Europe to that in European Union?
Provide a short and direct response. 1.57. What is the ratio of the Expenses (% of total expenses) of Subsidies and Transfers in Central Europe to that in European Union?
Keep it short and to the point. 0.99. What is the ratio of the Expenses (% of total expenses) in Other expenses in Central Europe to that in European Union?
Keep it short and to the point. 1.19. What is the ratio of the Expenses (% of total expenses) of Compensation of employees in East Asia (all income levels) to that in Euro area?
Provide a short and direct response. 1.71. What is the ratio of the Expenses (% of total expenses) in Goods and services in East Asia (all income levels) to that in Euro area?
Give a very brief answer. 3.31. What is the ratio of the Expenses (% of total expenses) of Subsidies and Transfers in East Asia (all income levels) to that in Euro area?
Provide a short and direct response. 0.61. What is the ratio of the Expenses (% of total expenses) of Other expenses in East Asia (all income levels) to that in Euro area?
Your response must be concise. 0.99. What is the ratio of the Expenses (% of total expenses) of Compensation of employees in East Asia (all income levels) to that in Europe(all income levels)?
Offer a terse response. 1.88. What is the ratio of the Expenses (% of total expenses) in Goods and services in East Asia (all income levels) to that in Europe(all income levels)?
Offer a terse response. 2.46. What is the ratio of the Expenses (% of total expenses) in Subsidies and Transfers in East Asia (all income levels) to that in Europe(all income levels)?
Provide a short and direct response. 0.63. What is the ratio of the Expenses (% of total expenses) of Other expenses in East Asia (all income levels) to that in Europe(all income levels)?
Make the answer very short. 0.7. What is the ratio of the Expenses (% of total expenses) in Compensation of employees in East Asia (all income levels) to that in European Union?
Keep it short and to the point. 1.88. What is the ratio of the Expenses (% of total expenses) in Goods and services in East Asia (all income levels) to that in European Union?
Your response must be concise. 2.89. What is the ratio of the Expenses (% of total expenses) of Subsidies and Transfers in East Asia (all income levels) to that in European Union?
Ensure brevity in your answer.  0.63. What is the ratio of the Expenses (% of total expenses) of Other expenses in East Asia (all income levels) to that in European Union?
Keep it short and to the point. 0.7. What is the ratio of the Expenses (% of total expenses) in Compensation of employees in Euro area to that in Europe(all income levels)?
Your answer should be very brief. 1.1. What is the ratio of the Expenses (% of total expenses) of Goods and services in Euro area to that in Europe(all income levels)?
Offer a terse response. 0.74. What is the ratio of the Expenses (% of total expenses) in Subsidies and Transfers in Euro area to that in Europe(all income levels)?
Keep it short and to the point. 1.03. What is the ratio of the Expenses (% of total expenses) of Other expenses in Euro area to that in Europe(all income levels)?
Offer a very short reply. 0.7. What is the ratio of the Expenses (% of total expenses) in Compensation of employees in Euro area to that in European Union?
Make the answer very short. 1.1. What is the ratio of the Expenses (% of total expenses) of Goods and services in Euro area to that in European Union?
Your response must be concise. 0.87. What is the ratio of the Expenses (% of total expenses) of Subsidies and Transfers in Euro area to that in European Union?
Keep it short and to the point. 1.04. What is the ratio of the Expenses (% of total expenses) of Other expenses in Euro area to that in European Union?
Offer a terse response. 0.7. What is the ratio of the Expenses (% of total expenses) in Goods and services in Europe(all income levels) to that in European Union?
Make the answer very short. 1.17. What is the ratio of the Expenses (% of total expenses) in Subsidies and Transfers in Europe(all income levels) to that in European Union?
Provide a short and direct response. 1.01. What is the ratio of the Expenses (% of total expenses) in Other expenses in Europe(all income levels) to that in European Union?
Give a very brief answer. 1. What is the difference between the highest and the second highest Expenses (% of total expenses) in Compensation of employees?
Make the answer very short. 11.15. What is the difference between the highest and the second highest Expenses (% of total expenses) of Goods and services?
Offer a very short reply. 10.1. What is the difference between the highest and the second highest Expenses (% of total expenses) of Subsidies and Transfers?
Your response must be concise. 1.62. What is the difference between the highest and the second highest Expenses (% of total expenses) in Other expenses?
Keep it short and to the point. 1.09. What is the difference between the highest and the lowest Expenses (% of total expenses) in Compensation of employees?
Make the answer very short. 23.6. What is the difference between the highest and the lowest Expenses (% of total expenses) of Goods and services?
Give a very brief answer. 17.03. What is the difference between the highest and the lowest Expenses (% of total expenses) in Subsidies and Transfers?
Offer a very short reply. 29.44. What is the difference between the highest and the lowest Expenses (% of total expenses) of Other expenses?
Offer a very short reply. 5.58. 